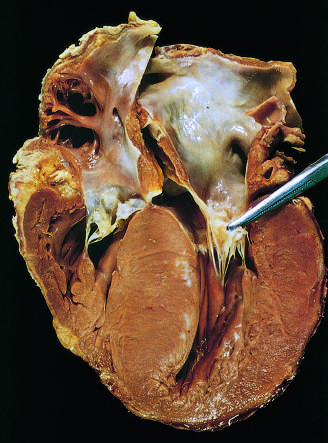what has the anterior mitral leaflet been moved away from?
Answer the question using a single word or phrase. The septum 